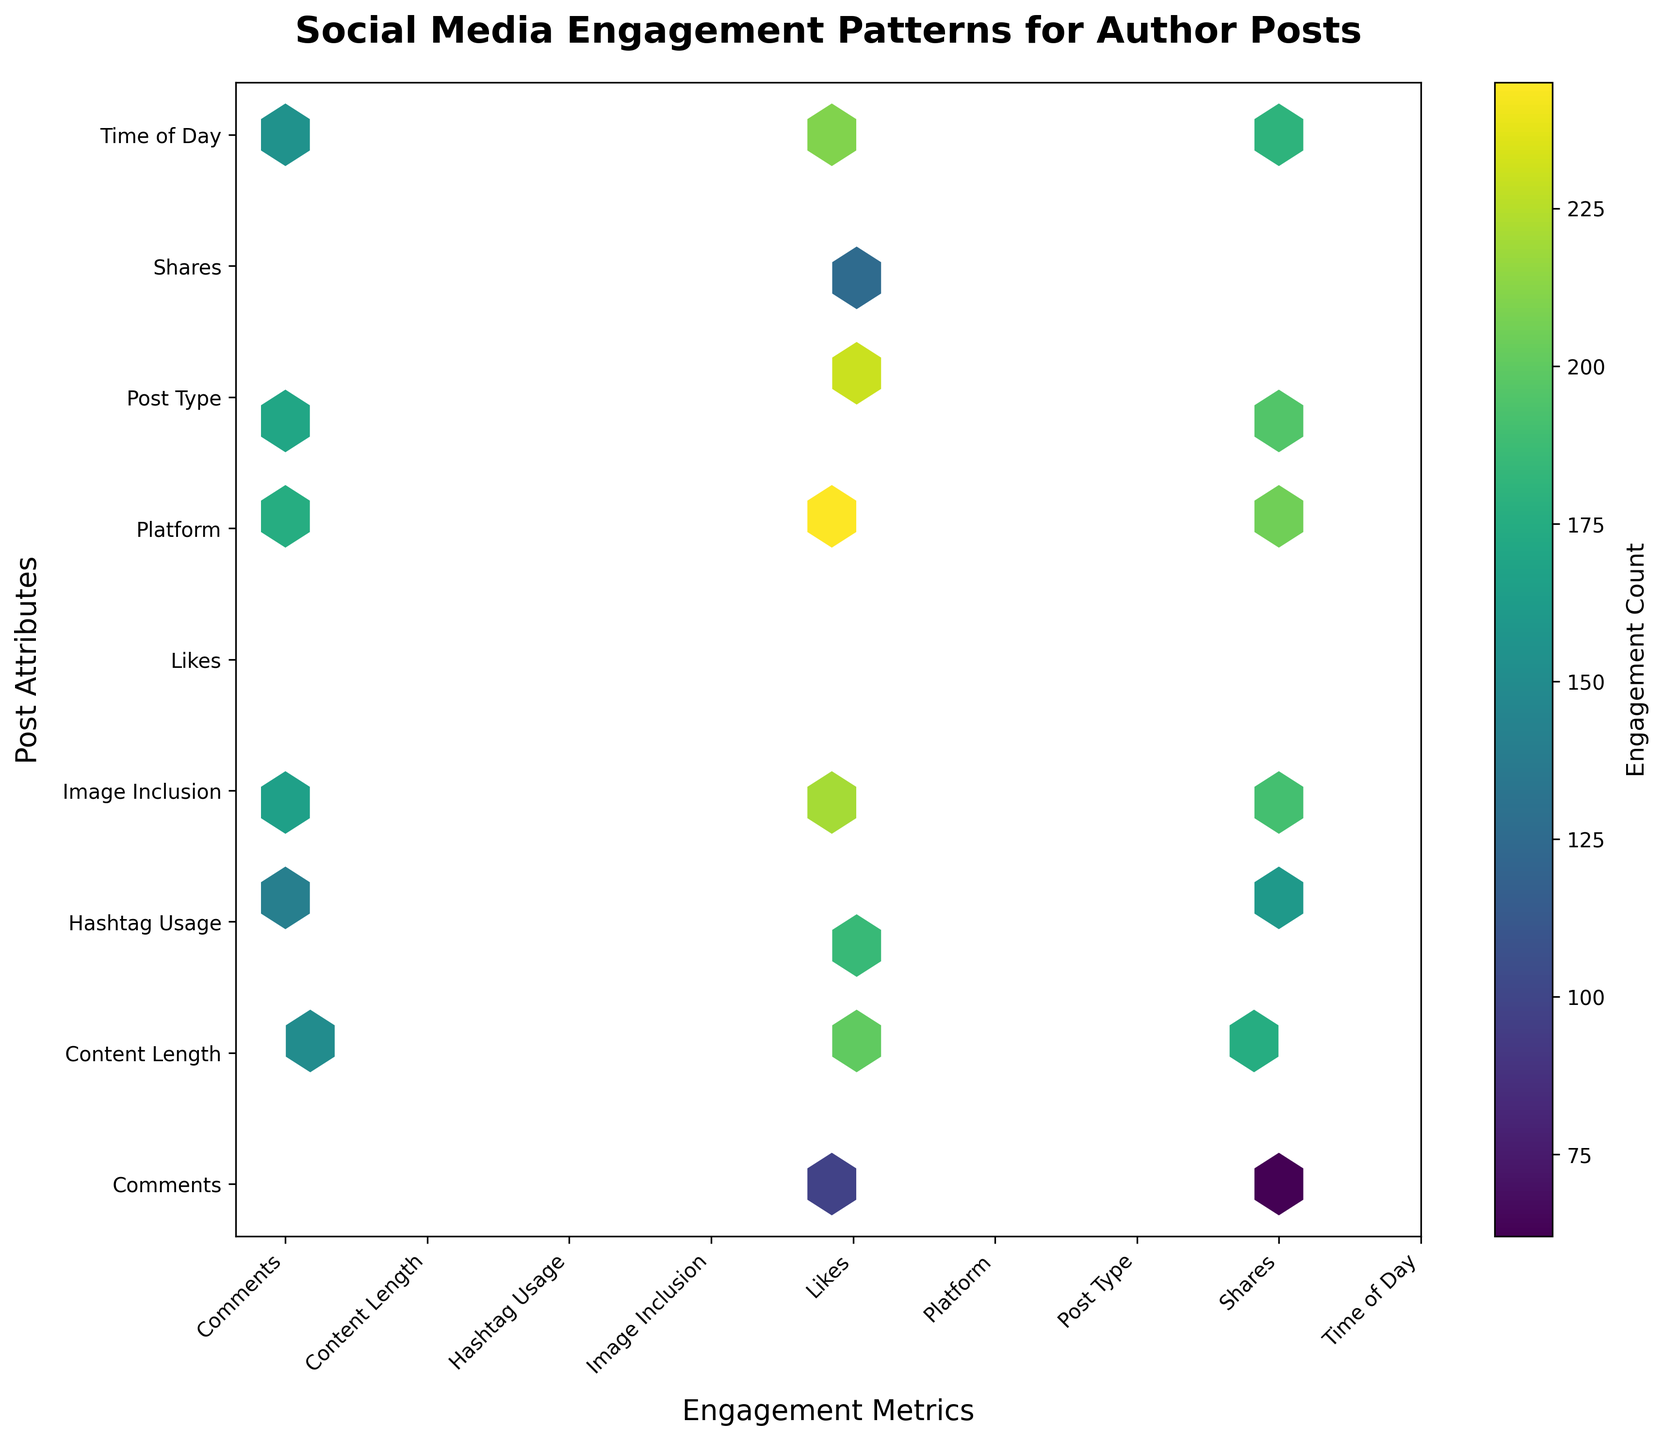What is the title of the plot? The title is displayed at the top of the plot. It reads "Social Media Engagement Patterns for Author Posts".
Answer: Social Media Engagement Patterns for Author Posts What are the labels of the x and y axes? The x-axis label is "Engagement Metrics," and the y-axis label is "Post Attributes." These labels are placed near the respective axes of the plot.
Answer: Engagement Metrics, Post Attributes Which engagement metric has the highest count when paired with Platform? To find this, look at the hex cells where 'Platform' is on the y-axis and compare the counts for 'Likes,' 'Shares,' and 'Comments' on the x-axis. The highest count for Platform is 245 for Likes.
Answer: Likes How many unique values are used in both the x and y axes? Count the unique terms listed on both axes. The terms are Likes, Shares, Comments, Time of Day, Post Type, Hashtag Usage, Platform, Content Length, and Image Inclusion, totaling 9 unique values.
Answer: 9 What is the color representing in this hexbin plot? The color represents the engagement count. This can be inferred from the color bar on the side of the plot labeled 'Engagement Count.'
Answer: Engagement count What is the engagement count associated with Hashtag Usage and Likes? Locate the hex cell where 'Likes' on the x-axis intersects with 'Hashtag Usage' on the y-axis. The count shown for this intersection is 185.
Answer: 185 How does the engagement count of 'Comments' and 'Time of Day' compare to 'Shares' and 'Time of Day'? Find the counts at these intersections: For 'Comments' and 'Time of Day,' the count is 155. For 'Shares' and 'Time of Day,' it is 180. Comparatively, 'Shares' and 'Time of Day' have a higher engagement count.
Answer: Shares and Time of Day > Comments and Time of Day Which pairing shows the highest engagement count overall? Look at the color intensity and the numerical data for the cells. The highest engagement count is 245, which corresponds to 'Likes' and 'Platform.'
Answer: Likes and Platform What is the difference in engagement counts between 'Shares' and 'Platform' and 'Shares' and 'Content Length'? Find the respective counts: 'Shares' and 'Platform' is 205, and 'Shares' and 'Content Length' is 175. The difference is 205 - 175 = 30.
Answer: 30 What can you infer about the impact of 'Image Inclusion' on 'Likes' compared to 'Shares'? Compare the engagement counts for 'Image Inclusion' for both 'Likes' and 'Shares.' 'Likes' has an engagement count of 220, while 'Shares' has 190. This indicates that posts with images are liked more often than they are shared.
Answer: Likes have higher impact 